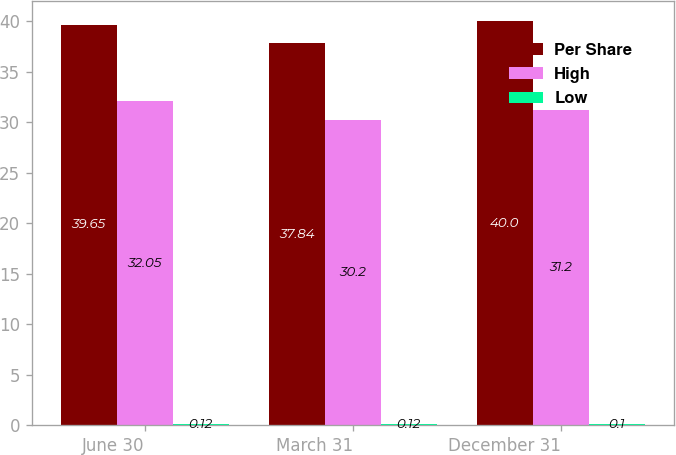<chart> <loc_0><loc_0><loc_500><loc_500><stacked_bar_chart><ecel><fcel>June 30<fcel>March 31<fcel>December 31<nl><fcel>Per Share<fcel>39.65<fcel>37.84<fcel>40<nl><fcel>High<fcel>32.05<fcel>30.2<fcel>31.2<nl><fcel>Low<fcel>0.12<fcel>0.12<fcel>0.1<nl></chart> 